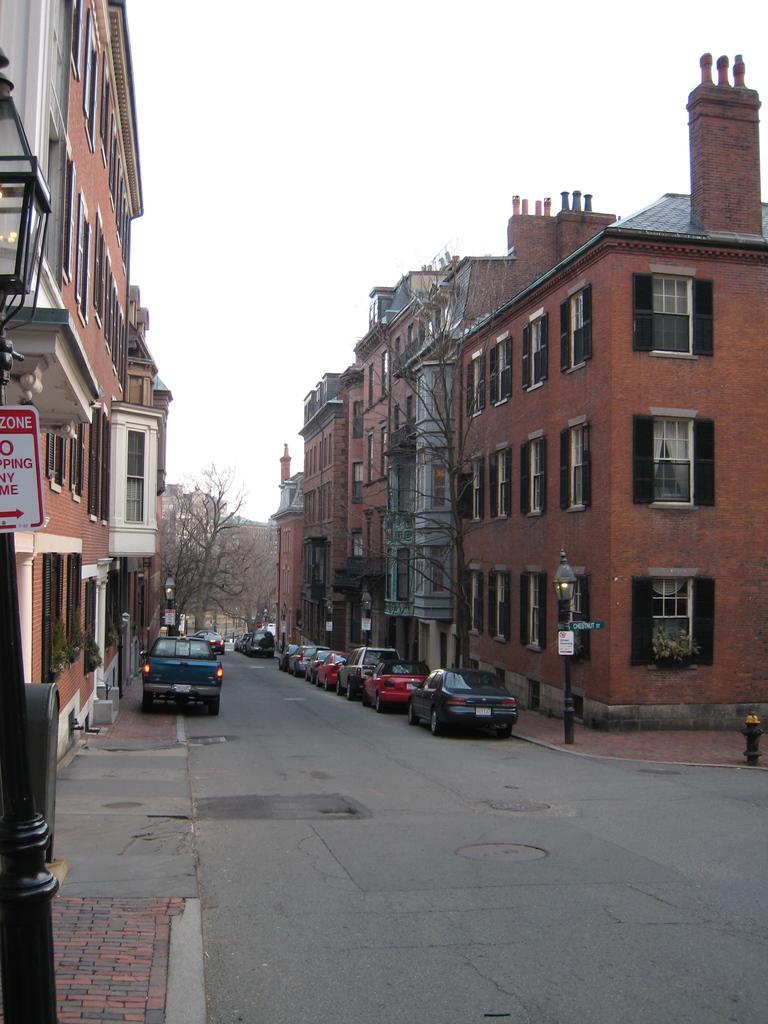Can you describe this image briefly? In the picture there are many vehicles parked beside the road and behind those vehicles there are many buildings. In the background there are few trees. 